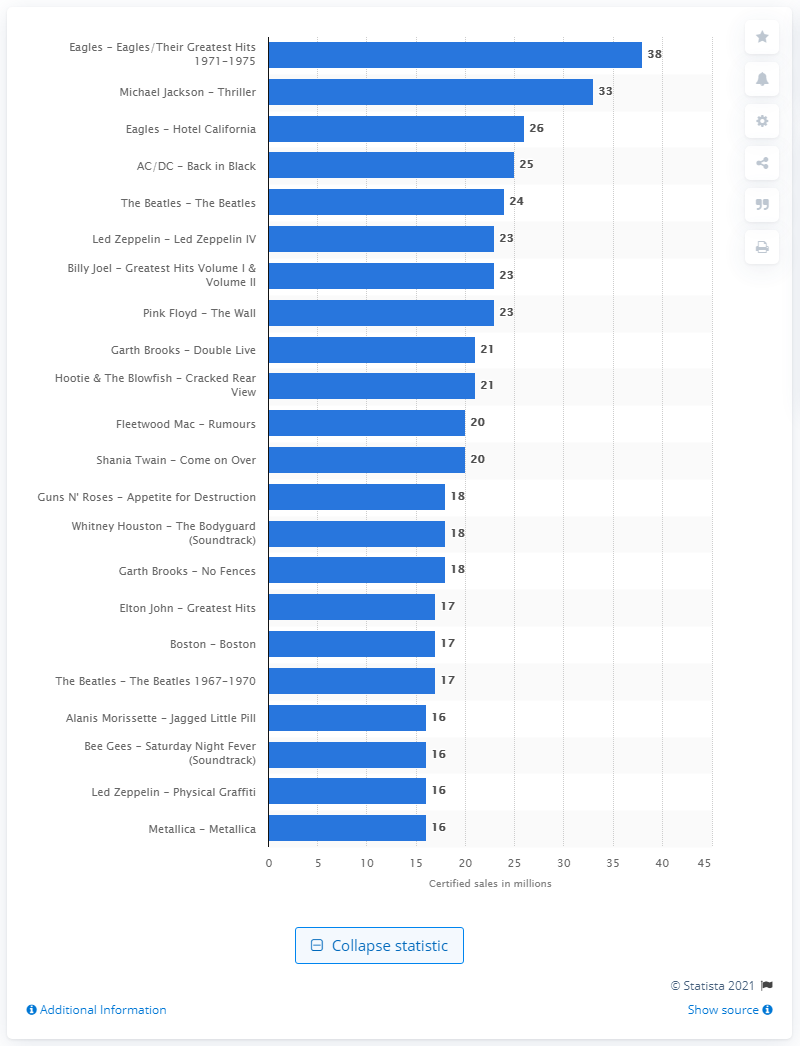Point out several critical features in this image. The sales of Eagles' Greatest Hits have reached 38 million copies. 